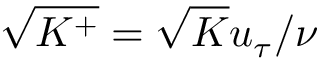Convert formula to latex. <formula><loc_0><loc_0><loc_500><loc_500>\sqrt { K ^ { + } } = \sqrt { K } u _ { \tau } / \nu</formula> 